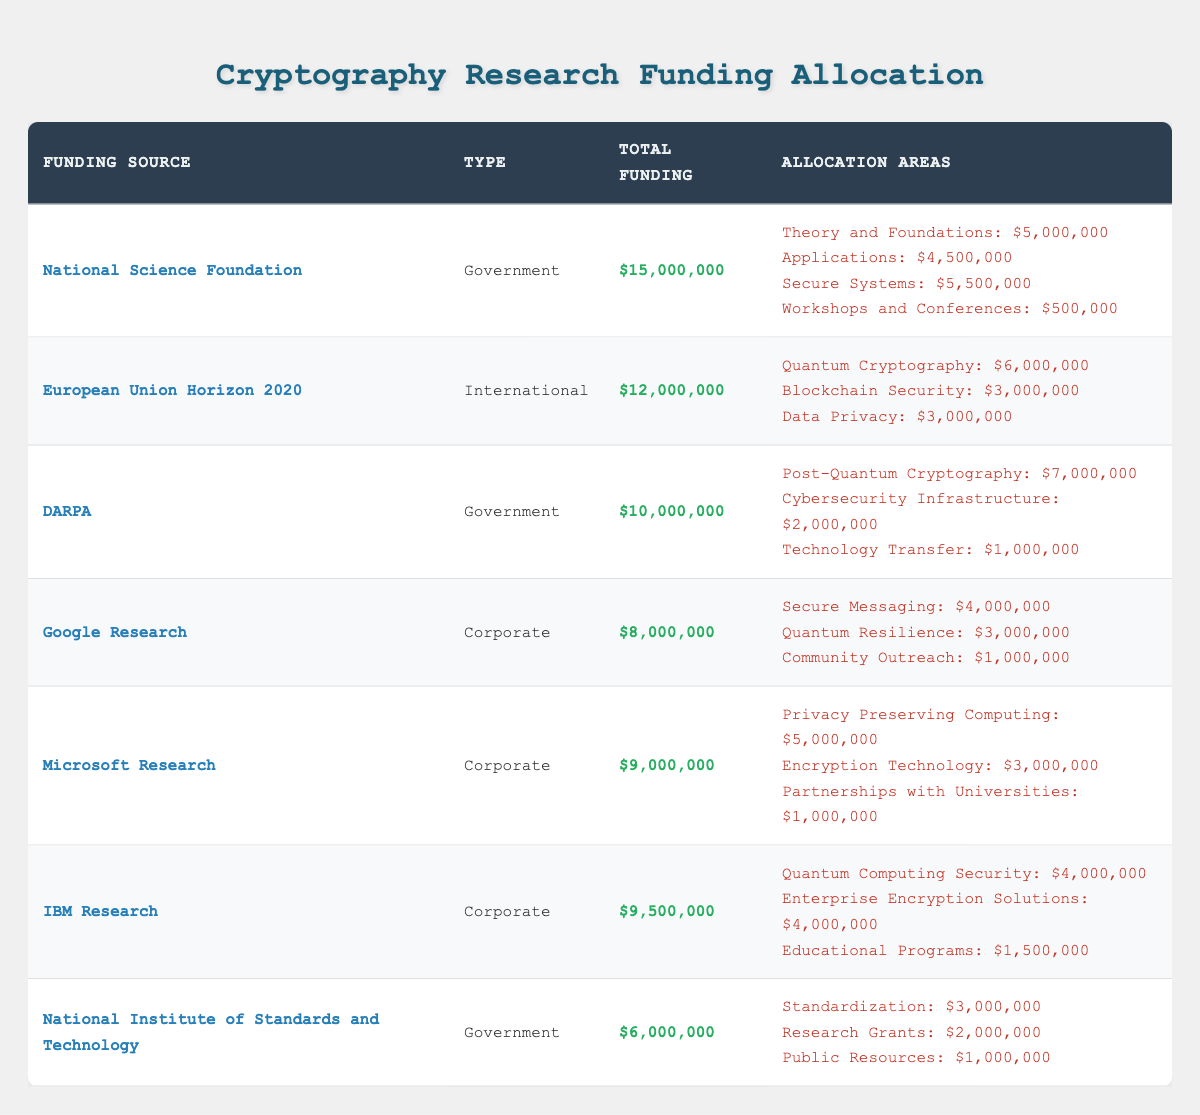What is the total funding from the National Science Foundation? The total funding is directly listed in the table under the National Science Foundation row as $15,000,000.
Answer: $15,000,000 How much funding is allocated to secure systems by the National Science Foundation? The allocation for secure systems is listed under the National Science Foundation as $5,500,000.
Answer: $5,500,000 Which funding source has the highest total funding amount? By comparing the total funding amounts: National Science Foundation ($15,000,000), European Union Horizon 2020 ($12,000,000), and others, the highest is $15,000,000 from the National Science Foundation.
Answer: National Science Foundation What is the total funding amount for DARPA? The total funding amount for DARPA is mentioned in the table, which is $10,000,000.
Answer: $10,000,000 What is the combined total funding for corporate funding sources? Adding the corporate funding sources: Google Research ($8,000,000), Microsoft Research ($9,000,000), and IBM Research ($9,500,000) gives $8,000,000 + $9,000,000 + $9,500,000 = $26,500,000.
Answer: $26,500,000 Is the funding allocation for post-quantum cryptography greater than that for blockchain security? The allocation for post-quantum cryptography from DARPA is $7,000,000, and for blockchain security from the European Union is $3,000,000; since $7,000,000 > $3,000,000, the statement is true.
Answer: Yes How much total funding is allocated for workshops and conferences compared to community outreach? The total funding for workshops and conferences from the National Science Foundation is $500,000, and for community outreach from Google Research is $1,000,000. Comparing these: $1,000,000 > $500,000, it shows that community outreach has more funding.
Answer: Community outreach has more funding Which government agency allocates the least total funding? The total funding for the National Institute of Standards and Technology is $6,000,000, which is less than the other government agencies (NSF and DARPA), making it the lowest.
Answer: National Institute of Standards and Technology How much more funding is allocated to quantum cryptography than to privacy preserving computing? The funding for quantum cryptography from the EU is $6,000,000, while for privacy preserving computing from Microsoft is $5,000,000. The difference is $6,000,000 - $5,000,000 = $1,000,000.
Answer: $1,000,000 What percentage of the total funding for IBM Research is allocated to educational programs? The total funding for IBM Research is $9,500,000, and the allocation for educational programs is $1,500,000. The percentage is calculated as ($1,500,000 / $9,500,000) * 100 ≈ 15.79%.
Answer: Approximately 15.79% 